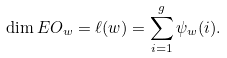Convert formula to latex. <formula><loc_0><loc_0><loc_500><loc_500>\dim E O _ { w } = \ell ( w ) = \sum _ { i = 1 } ^ { g } \psi _ { w } ( i ) .</formula> 